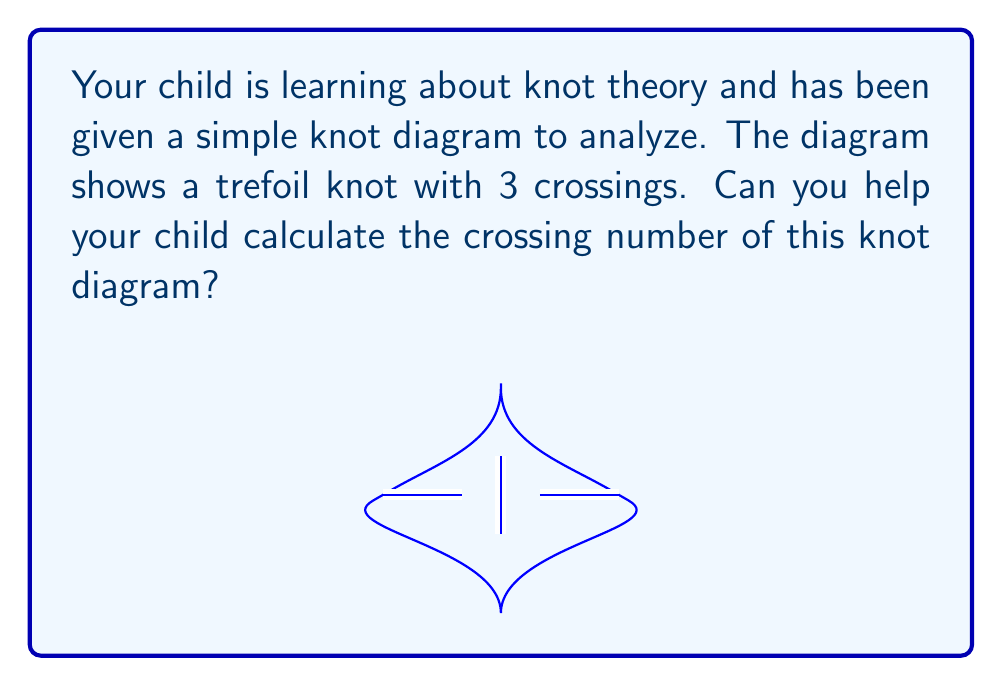What is the answer to this math problem? Let's approach this step-by-step:

1) The crossing number of a knot diagram is defined as the number of crossings in the diagram.

2) In this case, we're looking at a trefoil knot. Let's count the crossings:

   a) There's a crossing at the top of the diagram.
   b) There's another crossing on the bottom left.
   c) There's a third crossing on the bottom right.

3) We can see that there are exactly 3 points where the knot crosses over itself.

4) Each of these crossings contributes to the crossing number.

5) Therefore, we simply need to count these crossings to determine the crossing number.

It's important to note that the crossing number we've calculated here is specific to this particular diagram of the trefoil knot. In knot theory, we're often interested in the minimum crossing number over all possible diagrams of a knot, but that's not what we're asked to find here.
Answer: 3 